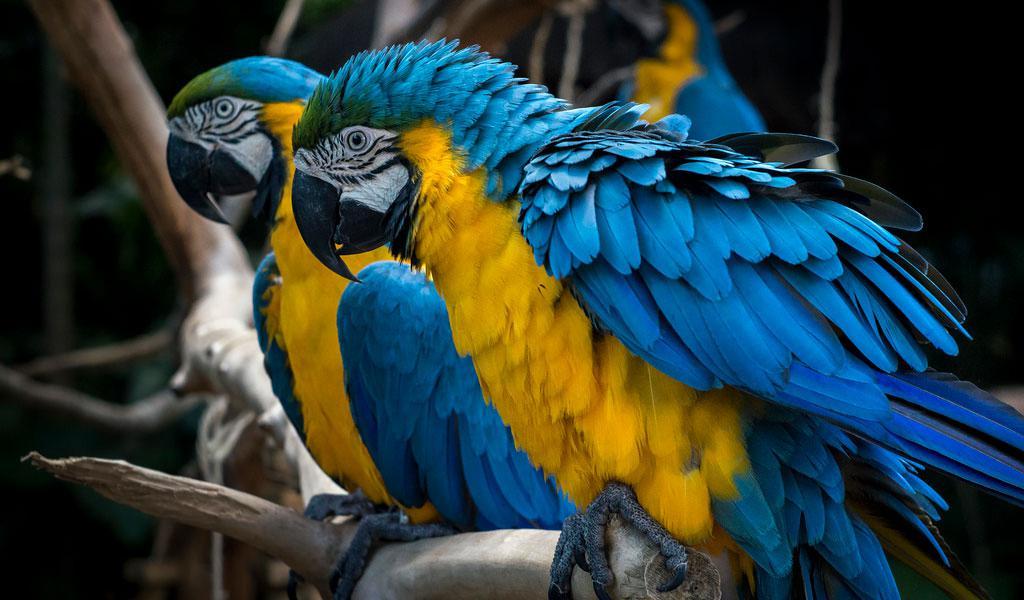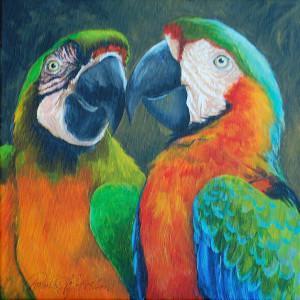The first image is the image on the left, the second image is the image on the right. Analyze the images presented: Is the assertion "There are two real birds with white faces in black beaks sitting next to each other on a branch." valid? Answer yes or no. Yes. 